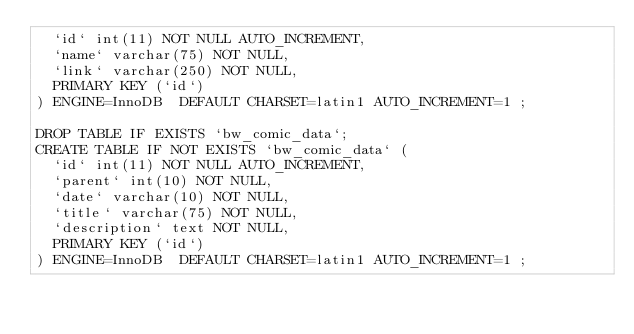<code> <loc_0><loc_0><loc_500><loc_500><_SQL_>  `id` int(11) NOT NULL AUTO_INCREMENT,
  `name` varchar(75) NOT NULL,
  `link` varchar(250) NOT NULL,
  PRIMARY KEY (`id`)
) ENGINE=InnoDB  DEFAULT CHARSET=latin1 AUTO_INCREMENT=1 ;

DROP TABLE IF EXISTS `bw_comic_data`;
CREATE TABLE IF NOT EXISTS `bw_comic_data` (
  `id` int(11) NOT NULL AUTO_INCREMENT,
  `parent` int(10) NOT NULL,
  `date` varchar(10) NOT NULL,
  `title` varchar(75) NOT NULL,
  `description` text NOT NULL,
  PRIMARY KEY (`id`)
) ENGINE=InnoDB  DEFAULT CHARSET=latin1 AUTO_INCREMENT=1 ;
</code> 